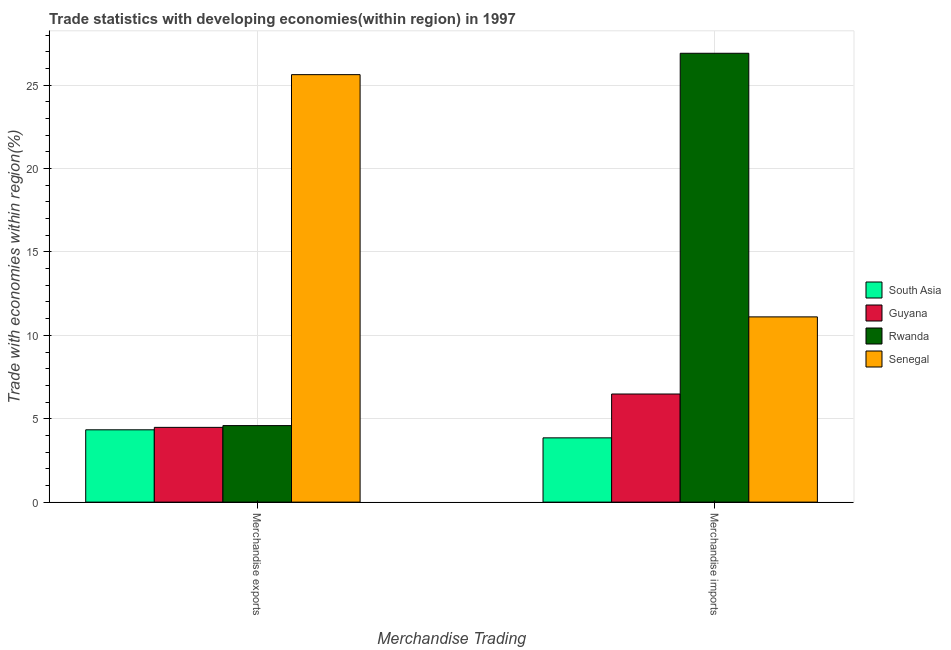How many groups of bars are there?
Give a very brief answer. 2. Are the number of bars per tick equal to the number of legend labels?
Provide a succinct answer. Yes. Are the number of bars on each tick of the X-axis equal?
Offer a very short reply. Yes. How many bars are there on the 1st tick from the left?
Keep it short and to the point. 4. How many bars are there on the 2nd tick from the right?
Offer a terse response. 4. What is the label of the 1st group of bars from the left?
Your answer should be compact. Merchandise exports. What is the merchandise imports in Rwanda?
Your answer should be very brief. 26.91. Across all countries, what is the maximum merchandise imports?
Provide a short and direct response. 26.91. Across all countries, what is the minimum merchandise exports?
Offer a very short reply. 4.34. In which country was the merchandise exports maximum?
Your answer should be compact. Senegal. What is the total merchandise imports in the graph?
Keep it short and to the point. 48.35. What is the difference between the merchandise imports in Senegal and that in Guyana?
Offer a terse response. 4.62. What is the difference between the merchandise exports in South Asia and the merchandise imports in Senegal?
Provide a short and direct response. -6.77. What is the average merchandise imports per country?
Your response must be concise. 12.09. What is the difference between the merchandise exports and merchandise imports in Senegal?
Your answer should be very brief. 14.52. What is the ratio of the merchandise exports in Rwanda to that in Guyana?
Your answer should be very brief. 1.02. Is the merchandise imports in Senegal less than that in Rwanda?
Give a very brief answer. Yes. What does the 2nd bar from the left in Merchandise imports represents?
Offer a very short reply. Guyana. What does the 4th bar from the right in Merchandise exports represents?
Provide a succinct answer. South Asia. How many countries are there in the graph?
Give a very brief answer. 4. What is the difference between two consecutive major ticks on the Y-axis?
Provide a short and direct response. 5. Does the graph contain grids?
Offer a very short reply. Yes. What is the title of the graph?
Offer a terse response. Trade statistics with developing economies(within region) in 1997. What is the label or title of the X-axis?
Provide a succinct answer. Merchandise Trading. What is the label or title of the Y-axis?
Your answer should be very brief. Trade with economies within region(%). What is the Trade with economies within region(%) in South Asia in Merchandise exports?
Give a very brief answer. 4.34. What is the Trade with economies within region(%) of Guyana in Merchandise exports?
Make the answer very short. 4.48. What is the Trade with economies within region(%) in Rwanda in Merchandise exports?
Offer a terse response. 4.59. What is the Trade with economies within region(%) in Senegal in Merchandise exports?
Make the answer very short. 25.63. What is the Trade with economies within region(%) in South Asia in Merchandise imports?
Provide a succinct answer. 3.85. What is the Trade with economies within region(%) in Guyana in Merchandise imports?
Offer a terse response. 6.48. What is the Trade with economies within region(%) in Rwanda in Merchandise imports?
Give a very brief answer. 26.91. What is the Trade with economies within region(%) of Senegal in Merchandise imports?
Your answer should be compact. 11.11. Across all Merchandise Trading, what is the maximum Trade with economies within region(%) in South Asia?
Provide a short and direct response. 4.34. Across all Merchandise Trading, what is the maximum Trade with economies within region(%) of Guyana?
Make the answer very short. 6.48. Across all Merchandise Trading, what is the maximum Trade with economies within region(%) of Rwanda?
Your answer should be compact. 26.91. Across all Merchandise Trading, what is the maximum Trade with economies within region(%) in Senegal?
Offer a terse response. 25.63. Across all Merchandise Trading, what is the minimum Trade with economies within region(%) of South Asia?
Offer a terse response. 3.85. Across all Merchandise Trading, what is the minimum Trade with economies within region(%) in Guyana?
Provide a succinct answer. 4.48. Across all Merchandise Trading, what is the minimum Trade with economies within region(%) of Rwanda?
Your answer should be compact. 4.59. Across all Merchandise Trading, what is the minimum Trade with economies within region(%) of Senegal?
Provide a short and direct response. 11.11. What is the total Trade with economies within region(%) in South Asia in the graph?
Your answer should be compact. 8.19. What is the total Trade with economies within region(%) in Guyana in the graph?
Make the answer very short. 10.96. What is the total Trade with economies within region(%) of Rwanda in the graph?
Ensure brevity in your answer.  31.5. What is the total Trade with economies within region(%) of Senegal in the graph?
Provide a short and direct response. 36.74. What is the difference between the Trade with economies within region(%) of South Asia in Merchandise exports and that in Merchandise imports?
Your response must be concise. 0.48. What is the difference between the Trade with economies within region(%) of Guyana in Merchandise exports and that in Merchandise imports?
Provide a succinct answer. -2. What is the difference between the Trade with economies within region(%) of Rwanda in Merchandise exports and that in Merchandise imports?
Keep it short and to the point. -22.32. What is the difference between the Trade with economies within region(%) in Senegal in Merchandise exports and that in Merchandise imports?
Your answer should be compact. 14.52. What is the difference between the Trade with economies within region(%) of South Asia in Merchandise exports and the Trade with economies within region(%) of Guyana in Merchandise imports?
Your response must be concise. -2.15. What is the difference between the Trade with economies within region(%) in South Asia in Merchandise exports and the Trade with economies within region(%) in Rwanda in Merchandise imports?
Provide a short and direct response. -22.58. What is the difference between the Trade with economies within region(%) of South Asia in Merchandise exports and the Trade with economies within region(%) of Senegal in Merchandise imports?
Offer a terse response. -6.77. What is the difference between the Trade with economies within region(%) of Guyana in Merchandise exports and the Trade with economies within region(%) of Rwanda in Merchandise imports?
Give a very brief answer. -22.43. What is the difference between the Trade with economies within region(%) in Guyana in Merchandise exports and the Trade with economies within region(%) in Senegal in Merchandise imports?
Make the answer very short. -6.62. What is the difference between the Trade with economies within region(%) in Rwanda in Merchandise exports and the Trade with economies within region(%) in Senegal in Merchandise imports?
Your answer should be compact. -6.52. What is the average Trade with economies within region(%) in South Asia per Merchandise Trading?
Keep it short and to the point. 4.09. What is the average Trade with economies within region(%) of Guyana per Merchandise Trading?
Provide a short and direct response. 5.48. What is the average Trade with economies within region(%) in Rwanda per Merchandise Trading?
Keep it short and to the point. 15.75. What is the average Trade with economies within region(%) of Senegal per Merchandise Trading?
Make the answer very short. 18.37. What is the difference between the Trade with economies within region(%) in South Asia and Trade with economies within region(%) in Guyana in Merchandise exports?
Your response must be concise. -0.15. What is the difference between the Trade with economies within region(%) of South Asia and Trade with economies within region(%) of Rwanda in Merchandise exports?
Your answer should be compact. -0.25. What is the difference between the Trade with economies within region(%) of South Asia and Trade with economies within region(%) of Senegal in Merchandise exports?
Your answer should be compact. -21.29. What is the difference between the Trade with economies within region(%) in Guyana and Trade with economies within region(%) in Rwanda in Merchandise exports?
Offer a very short reply. -0.11. What is the difference between the Trade with economies within region(%) of Guyana and Trade with economies within region(%) of Senegal in Merchandise exports?
Offer a terse response. -21.15. What is the difference between the Trade with economies within region(%) in Rwanda and Trade with economies within region(%) in Senegal in Merchandise exports?
Give a very brief answer. -21.04. What is the difference between the Trade with economies within region(%) in South Asia and Trade with economies within region(%) in Guyana in Merchandise imports?
Provide a succinct answer. -2.63. What is the difference between the Trade with economies within region(%) of South Asia and Trade with economies within region(%) of Rwanda in Merchandise imports?
Your answer should be compact. -23.06. What is the difference between the Trade with economies within region(%) of South Asia and Trade with economies within region(%) of Senegal in Merchandise imports?
Keep it short and to the point. -7.25. What is the difference between the Trade with economies within region(%) of Guyana and Trade with economies within region(%) of Rwanda in Merchandise imports?
Offer a very short reply. -20.43. What is the difference between the Trade with economies within region(%) in Guyana and Trade with economies within region(%) in Senegal in Merchandise imports?
Make the answer very short. -4.62. What is the difference between the Trade with economies within region(%) of Rwanda and Trade with economies within region(%) of Senegal in Merchandise imports?
Provide a succinct answer. 15.8. What is the ratio of the Trade with economies within region(%) in South Asia in Merchandise exports to that in Merchandise imports?
Ensure brevity in your answer.  1.13. What is the ratio of the Trade with economies within region(%) of Guyana in Merchandise exports to that in Merchandise imports?
Give a very brief answer. 0.69. What is the ratio of the Trade with economies within region(%) of Rwanda in Merchandise exports to that in Merchandise imports?
Provide a short and direct response. 0.17. What is the ratio of the Trade with economies within region(%) in Senegal in Merchandise exports to that in Merchandise imports?
Keep it short and to the point. 2.31. What is the difference between the highest and the second highest Trade with economies within region(%) of South Asia?
Your response must be concise. 0.48. What is the difference between the highest and the second highest Trade with economies within region(%) in Guyana?
Provide a succinct answer. 2. What is the difference between the highest and the second highest Trade with economies within region(%) in Rwanda?
Offer a terse response. 22.32. What is the difference between the highest and the second highest Trade with economies within region(%) of Senegal?
Keep it short and to the point. 14.52. What is the difference between the highest and the lowest Trade with economies within region(%) in South Asia?
Ensure brevity in your answer.  0.48. What is the difference between the highest and the lowest Trade with economies within region(%) in Guyana?
Give a very brief answer. 2. What is the difference between the highest and the lowest Trade with economies within region(%) in Rwanda?
Your answer should be very brief. 22.32. What is the difference between the highest and the lowest Trade with economies within region(%) of Senegal?
Provide a short and direct response. 14.52. 